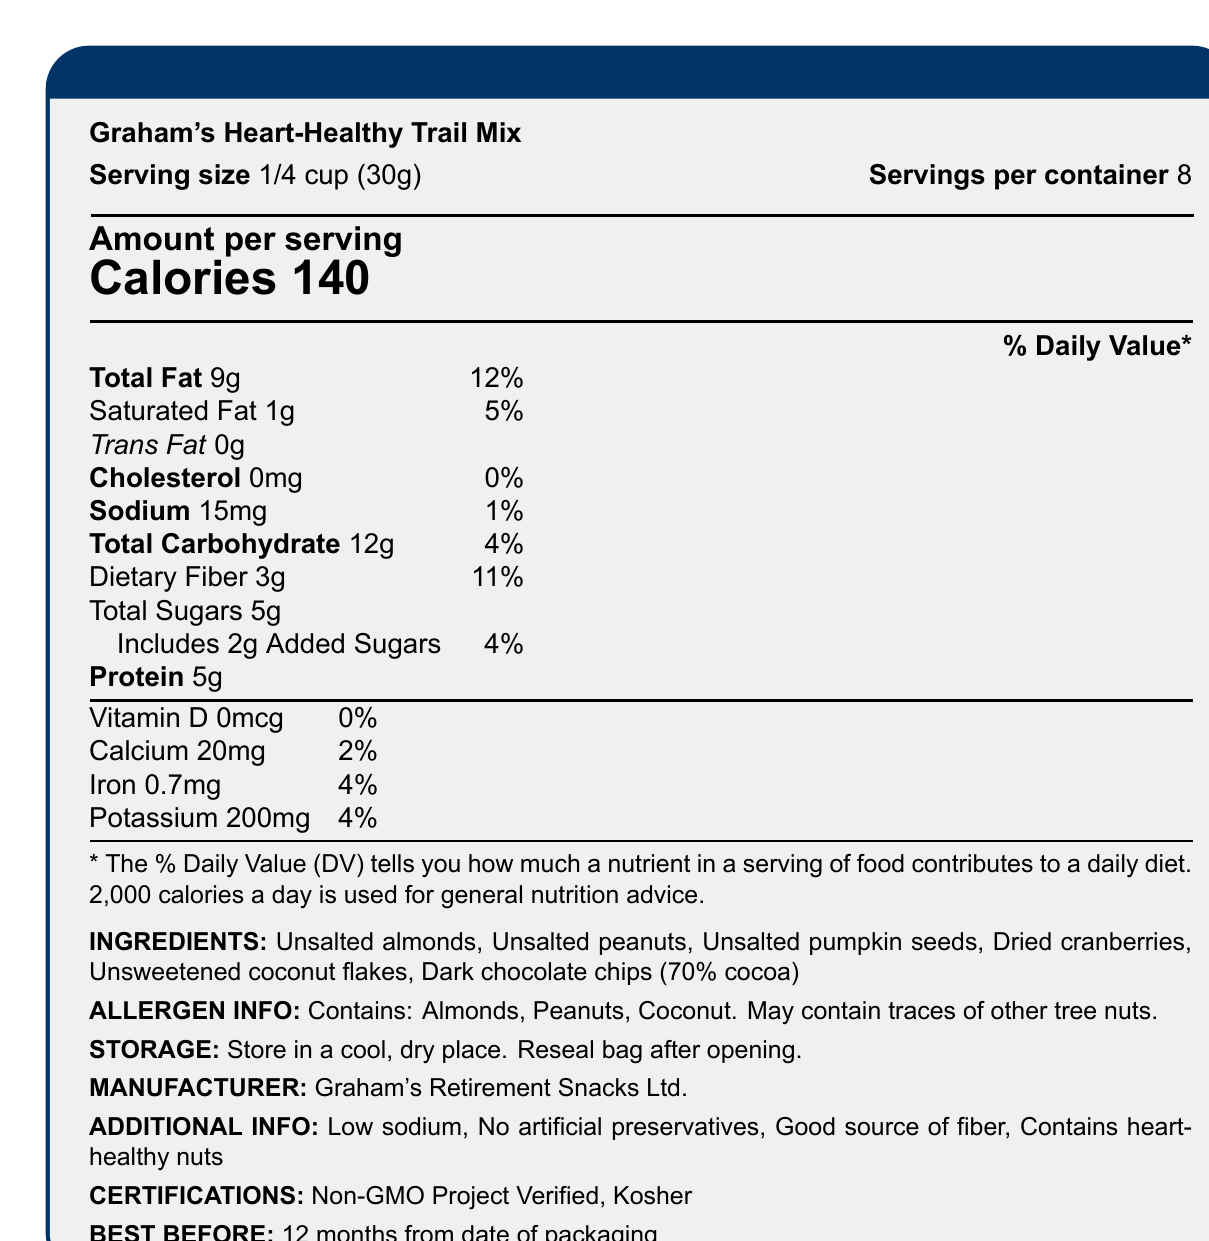what is the serving size? The serving size is clearly listed as "1/4 cup (30g)" on the Nutrition Facts label.
Answer: 1/4 cup (30g) how many calories are in one serving? The number of calories per serving is prominently displayed as 140.
Answer: 140 what is the amount of total fat per serving? The document lists the total fat per serving as 9g.
Answer: 9g how much sodium is in each serving? Each serving contains 15mg of sodium according to the Nutrition Facts.
Answer: 15mg how many grams of dietary fiber are in each serving? The dietary fiber content per serving is specified as 3g.
Answer: 3g what is the percent daily value of calcium per serving? A. 2% B. 4% C. 5% The provided document indicates that each serving has 2% of the daily value for calcium.
Answer: A. 2% which of the following is an ingredient in this trail mix? A. Salted Peanuts B. Raisins C. Unsweetened coconut flakes According to the ingredient list, "Unsweetened coconut flakes" are included in the trail mix.
Answer: C. Unsweetened coconut flakes does this trail mix contain any cholesterol? The document indicates that the cholesterol amount per serving is 0mg, meaning it contains no cholesterol.
Answer: No does the product have any certifications? The document states that the product is "Non-GMO Project Verified" and "Kosher".
Answer: Yes summarize the main idea of the document The document provides nutritional information, ingredients, allergen information, storage instructions, and certifications for Graham's Heart-Healthy Trail Mix, which is marketed as a healthy on-the-go snack.
Answer: Graham's Heart-Healthy Trail Mix is a low-sodium, high-fiber snack that includes a variety of nuts and dried fruits. It's designed to be heart-healthy with no artificial preservatives and is certified Non-GMO and Kosher. how much potassium is in each serving? The Nutrition Facts label specifies that each serving contains 200mg of potassium.
Answer: 200mg what is the serving size in grams? The serving size is listed as "1/4 cup (30g)" which converts to 30 grams.
Answer: 30g how many servings are there per container? Each container has 8 servings as mentioned in the document.
Answer: 8 what type of fat is completely absent from the trail mix? According to the Nutrition Facts, the trail mix contains 0g of trans fat.
Answer: Trans fat what allergen is not mentioned in the ingredients list? The allergen list mentions almonds, peanuts, and coconut but does not mention cashew.
Answer: Cashew is the trail mix considered low-sodium? The additional information section states that the trail mix is low sodium.
Answer: Yes how many grams of added sugar are present? The trail mix includes 2g of added sugars per serving.
Answer: 2g what is the name of the company that manufactures this product? The manufacturer is listed as "Graham's Retirement Snacks Ltd."
Answer: Graham's Retirement Snacks Ltd. what are the additional health benefits mentioned? The document highlights these additional health benefits in a dedicated section.
Answer: Low sodium, No artificial preservatives, Good source of fiber, Contains heart-healthy nuts when is the best before date for this product? The document states that the best before date is 12 months from the date of packaging.
Answer: 12 months from date of packaging how much protein is in each serving? The trail mix contains 5g of protein per serving.
Answer: 5g how many total carbohydrates are in each serving? The document lists the total carbohydrate content as 12g per serving.
Answer: 12g what is the daily value percentage of iron per serving? The listed daily value percentage for iron is 4%.
Answer: 4% what is the amount of vitamin D per serving? According to the Nutrition Facts, there is 0mcg of vitamin D per serving.
Answer: 0mcg can the total annual sales of this product be determined from the document? The document does not provide any sales data or related information.
Answer: Not enough information 